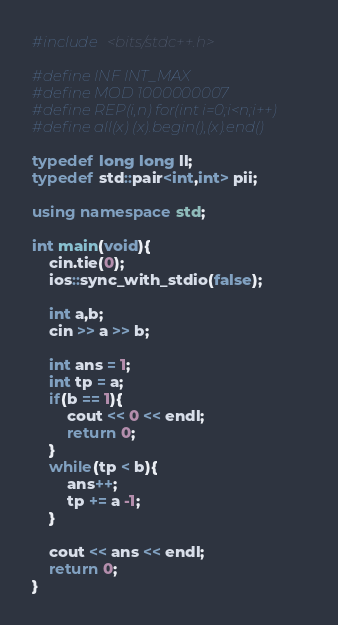Convert code to text. <code><loc_0><loc_0><loc_500><loc_500><_C++_>#include <bits/stdc++.h>

#define INF INT_MAX
#define MOD 1000000007
#define REP(i,n) for(int i=0;i<n;i++)
#define all(x) (x).begin(),(x).end()

typedef long long ll;
typedef std::pair<int,int> pii;

using namespace std;

int main(void){
    cin.tie(0);
    ios::sync_with_stdio(false);

    int a,b;
    cin >> a >> b;

    int ans = 1;
    int tp = a;
    if(b == 1){
        cout << 0 << endl;
        return 0;
    }
    while(tp < b){
        ans++;
        tp += a -1;
    }

    cout << ans << endl;
    return 0;
}    </code> 